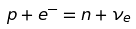Convert formula to latex. <formula><loc_0><loc_0><loc_500><loc_500>p + e ^ { - } = n + \nu _ { e }</formula> 